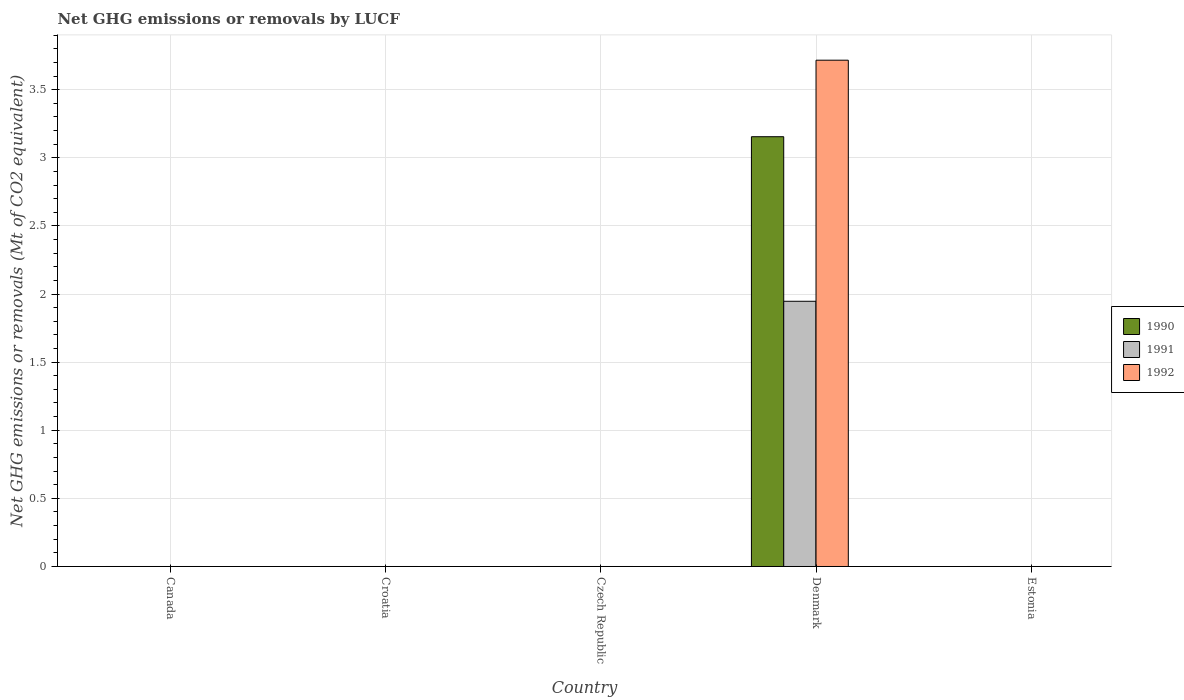How many different coloured bars are there?
Make the answer very short. 3. Are the number of bars per tick equal to the number of legend labels?
Offer a very short reply. No. How many bars are there on the 1st tick from the left?
Make the answer very short. 0. What is the label of the 3rd group of bars from the left?
Keep it short and to the point. Czech Republic. In how many cases, is the number of bars for a given country not equal to the number of legend labels?
Your answer should be compact. 4. Across all countries, what is the maximum net GHG emissions or removals by LUCF in 1990?
Give a very brief answer. 3.15. In which country was the net GHG emissions or removals by LUCF in 1991 maximum?
Make the answer very short. Denmark. What is the total net GHG emissions or removals by LUCF in 1992 in the graph?
Your answer should be very brief. 3.72. What is the difference between the net GHG emissions or removals by LUCF in 1991 in Estonia and the net GHG emissions or removals by LUCF in 1992 in Czech Republic?
Give a very brief answer. 0. What is the average net GHG emissions or removals by LUCF in 1992 per country?
Make the answer very short. 0.74. What is the difference between the net GHG emissions or removals by LUCF of/in 1992 and net GHG emissions or removals by LUCF of/in 1991 in Denmark?
Offer a terse response. 1.77. In how many countries, is the net GHG emissions or removals by LUCF in 1992 greater than 0.2 Mt?
Offer a terse response. 1. What is the difference between the highest and the lowest net GHG emissions or removals by LUCF in 1992?
Offer a terse response. 3.72. In how many countries, is the net GHG emissions or removals by LUCF in 1991 greater than the average net GHG emissions or removals by LUCF in 1991 taken over all countries?
Your answer should be very brief. 1. Is it the case that in every country, the sum of the net GHG emissions or removals by LUCF in 1992 and net GHG emissions or removals by LUCF in 1990 is greater than the net GHG emissions or removals by LUCF in 1991?
Your answer should be very brief. No. Does the graph contain grids?
Offer a very short reply. Yes. Where does the legend appear in the graph?
Give a very brief answer. Center right. How are the legend labels stacked?
Make the answer very short. Vertical. What is the title of the graph?
Offer a terse response. Net GHG emissions or removals by LUCF. Does "1961" appear as one of the legend labels in the graph?
Give a very brief answer. No. What is the label or title of the X-axis?
Give a very brief answer. Country. What is the label or title of the Y-axis?
Provide a short and direct response. Net GHG emissions or removals (Mt of CO2 equivalent). What is the Net GHG emissions or removals (Mt of CO2 equivalent) of 1990 in Canada?
Give a very brief answer. 0. What is the Net GHG emissions or removals (Mt of CO2 equivalent) of 1991 in Canada?
Provide a succinct answer. 0. What is the Net GHG emissions or removals (Mt of CO2 equivalent) of 1990 in Croatia?
Ensure brevity in your answer.  0. What is the Net GHG emissions or removals (Mt of CO2 equivalent) in 1990 in Czech Republic?
Offer a very short reply. 0. What is the Net GHG emissions or removals (Mt of CO2 equivalent) of 1990 in Denmark?
Ensure brevity in your answer.  3.15. What is the Net GHG emissions or removals (Mt of CO2 equivalent) of 1991 in Denmark?
Make the answer very short. 1.95. What is the Net GHG emissions or removals (Mt of CO2 equivalent) of 1992 in Denmark?
Provide a short and direct response. 3.72. What is the Net GHG emissions or removals (Mt of CO2 equivalent) of 1990 in Estonia?
Your answer should be very brief. 0. What is the Net GHG emissions or removals (Mt of CO2 equivalent) in 1991 in Estonia?
Ensure brevity in your answer.  0. Across all countries, what is the maximum Net GHG emissions or removals (Mt of CO2 equivalent) in 1990?
Provide a short and direct response. 3.15. Across all countries, what is the maximum Net GHG emissions or removals (Mt of CO2 equivalent) of 1991?
Provide a short and direct response. 1.95. Across all countries, what is the maximum Net GHG emissions or removals (Mt of CO2 equivalent) of 1992?
Your answer should be very brief. 3.72. Across all countries, what is the minimum Net GHG emissions or removals (Mt of CO2 equivalent) in 1992?
Provide a succinct answer. 0. What is the total Net GHG emissions or removals (Mt of CO2 equivalent) of 1990 in the graph?
Offer a terse response. 3.15. What is the total Net GHG emissions or removals (Mt of CO2 equivalent) in 1991 in the graph?
Offer a very short reply. 1.95. What is the total Net GHG emissions or removals (Mt of CO2 equivalent) of 1992 in the graph?
Make the answer very short. 3.72. What is the average Net GHG emissions or removals (Mt of CO2 equivalent) in 1990 per country?
Provide a succinct answer. 0.63. What is the average Net GHG emissions or removals (Mt of CO2 equivalent) in 1991 per country?
Your answer should be compact. 0.39. What is the average Net GHG emissions or removals (Mt of CO2 equivalent) of 1992 per country?
Your answer should be compact. 0.74. What is the difference between the Net GHG emissions or removals (Mt of CO2 equivalent) in 1990 and Net GHG emissions or removals (Mt of CO2 equivalent) in 1991 in Denmark?
Keep it short and to the point. 1.21. What is the difference between the Net GHG emissions or removals (Mt of CO2 equivalent) of 1990 and Net GHG emissions or removals (Mt of CO2 equivalent) of 1992 in Denmark?
Your answer should be very brief. -0.56. What is the difference between the Net GHG emissions or removals (Mt of CO2 equivalent) in 1991 and Net GHG emissions or removals (Mt of CO2 equivalent) in 1992 in Denmark?
Make the answer very short. -1.77. What is the difference between the highest and the lowest Net GHG emissions or removals (Mt of CO2 equivalent) in 1990?
Your response must be concise. 3.15. What is the difference between the highest and the lowest Net GHG emissions or removals (Mt of CO2 equivalent) of 1991?
Provide a succinct answer. 1.95. What is the difference between the highest and the lowest Net GHG emissions or removals (Mt of CO2 equivalent) of 1992?
Ensure brevity in your answer.  3.72. 